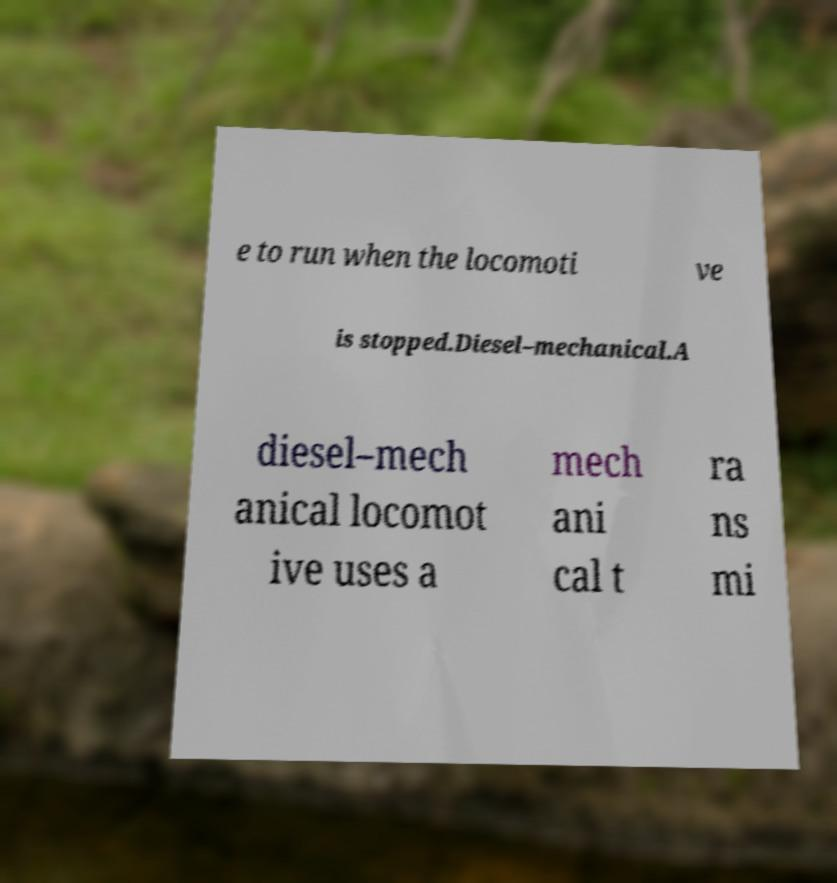Please identify and transcribe the text found in this image. e to run when the locomoti ve is stopped.Diesel–mechanical.A diesel–mech anical locomot ive uses a mech ani cal t ra ns mi 